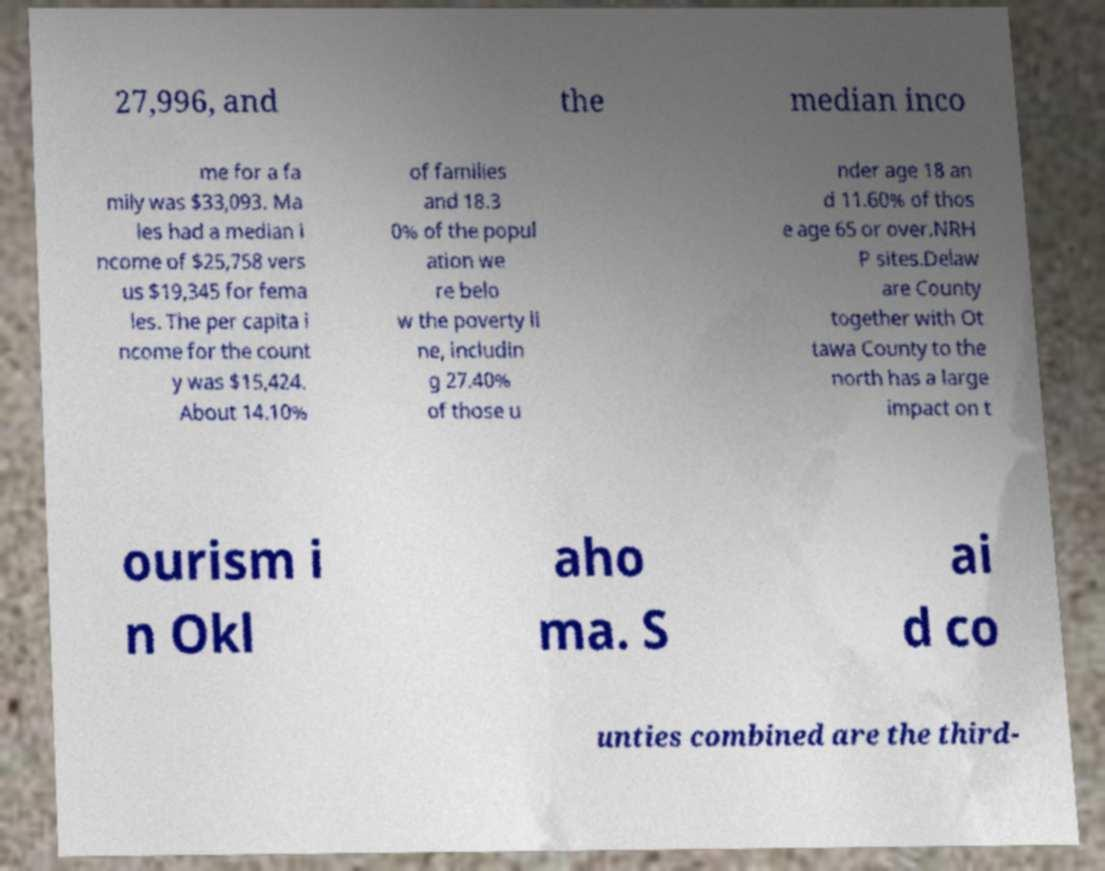I need the written content from this picture converted into text. Can you do that? 27,996, and the median inco me for a fa mily was $33,093. Ma les had a median i ncome of $25,758 vers us $19,345 for fema les. The per capita i ncome for the count y was $15,424. About 14.10% of families and 18.3 0% of the popul ation we re belo w the poverty li ne, includin g 27.40% of those u nder age 18 an d 11.60% of thos e age 65 or over.NRH P sites.Delaw are County together with Ot tawa County to the north has a large impact on t ourism i n Okl aho ma. S ai d co unties combined are the third- 